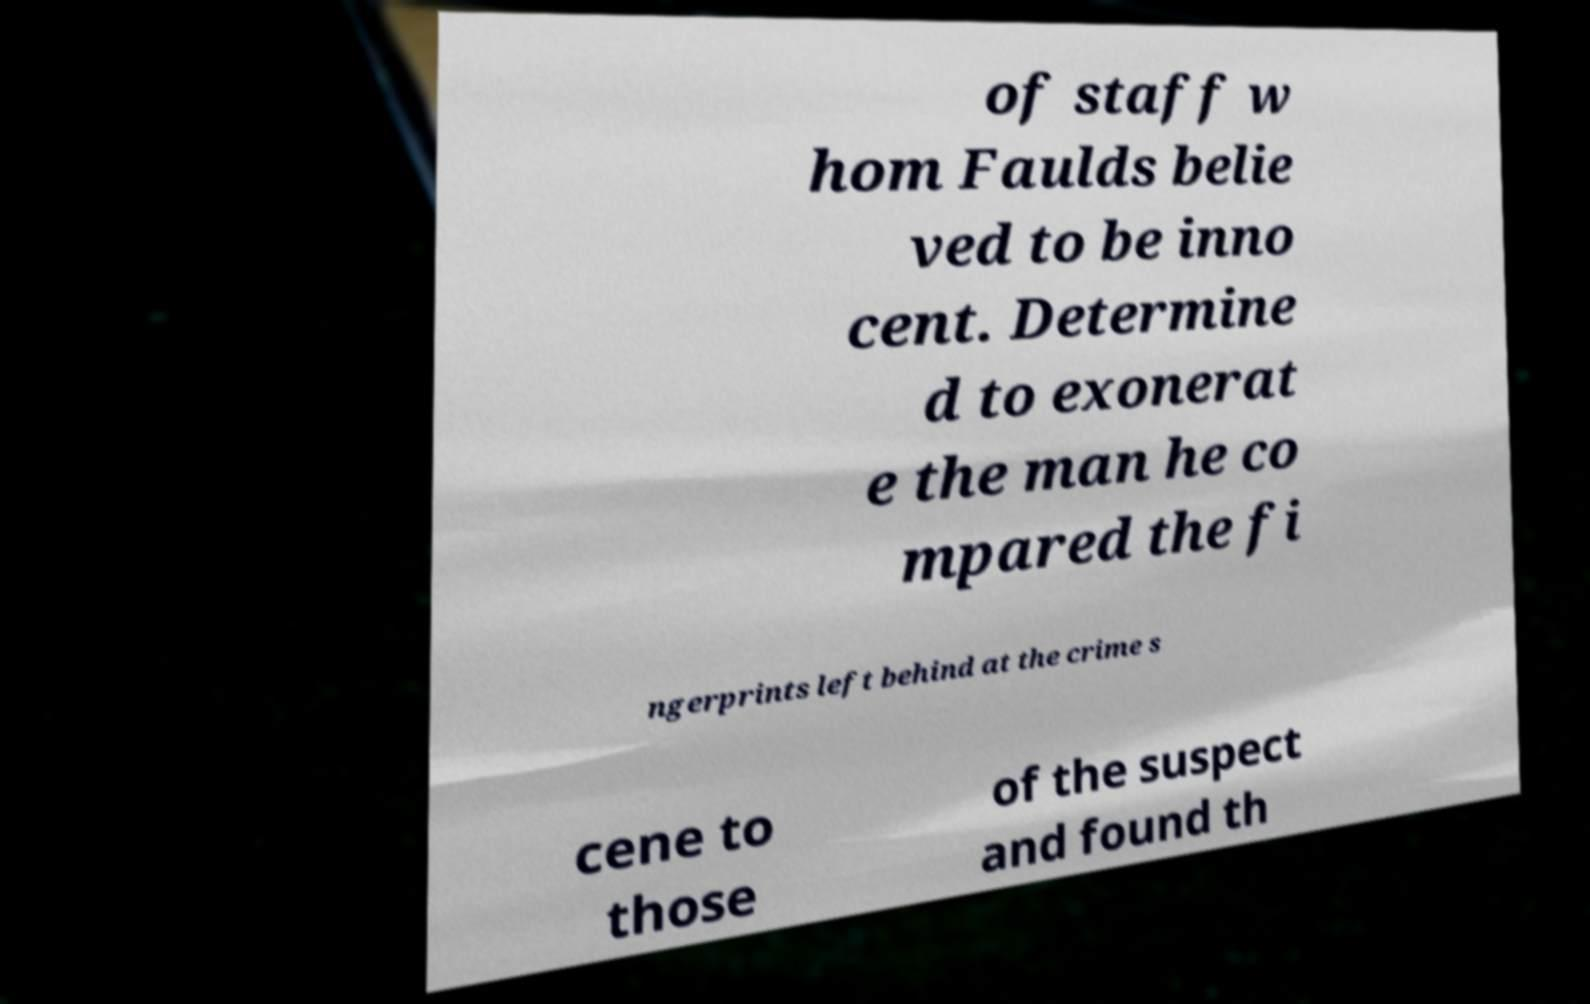Can you accurately transcribe the text from the provided image for me? of staff w hom Faulds belie ved to be inno cent. Determine d to exonerat e the man he co mpared the fi ngerprints left behind at the crime s cene to those of the suspect and found th 